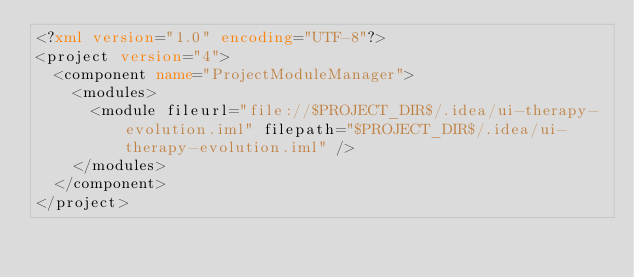<code> <loc_0><loc_0><loc_500><loc_500><_XML_><?xml version="1.0" encoding="UTF-8"?>
<project version="4">
  <component name="ProjectModuleManager">
    <modules>
      <module fileurl="file://$PROJECT_DIR$/.idea/ui-therapy-evolution.iml" filepath="$PROJECT_DIR$/.idea/ui-therapy-evolution.iml" />
    </modules>
  </component>
</project></code> 